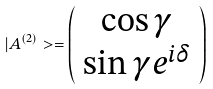Convert formula to latex. <formula><loc_0><loc_0><loc_500><loc_500>| A ^ { ( 2 ) } > = \left ( \begin{array} { c } \cos \gamma \\ \sin \gamma e ^ { i \delta } \end{array} \right )</formula> 